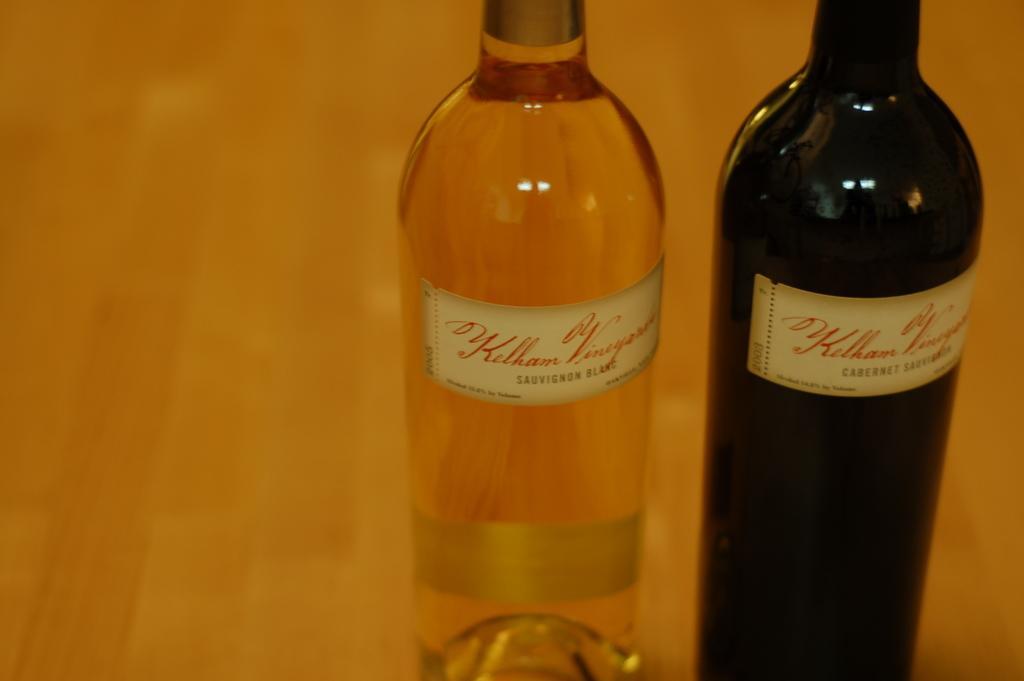Please provide a concise description of this image. In this picture we can see two bottles on a table. 